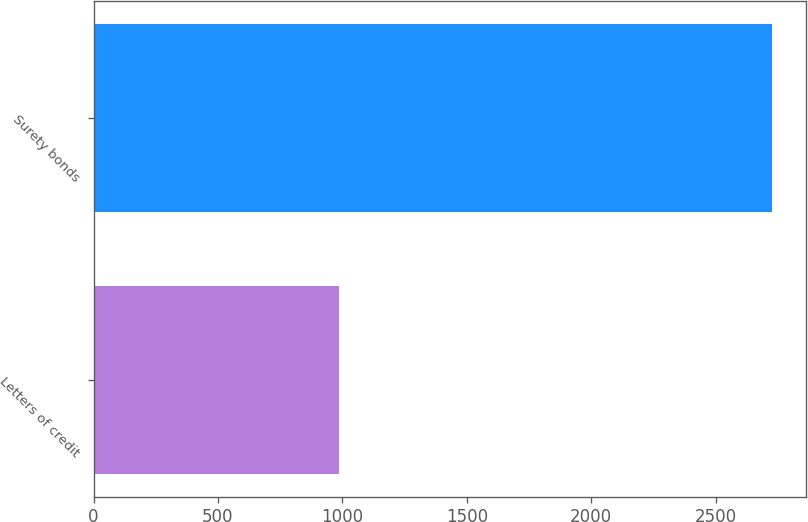Convert chart to OTSL. <chart><loc_0><loc_0><loc_500><loc_500><bar_chart><fcel>Letters of credit<fcel>Surety bonds<nl><fcel>987.8<fcel>2728.2<nl></chart> 